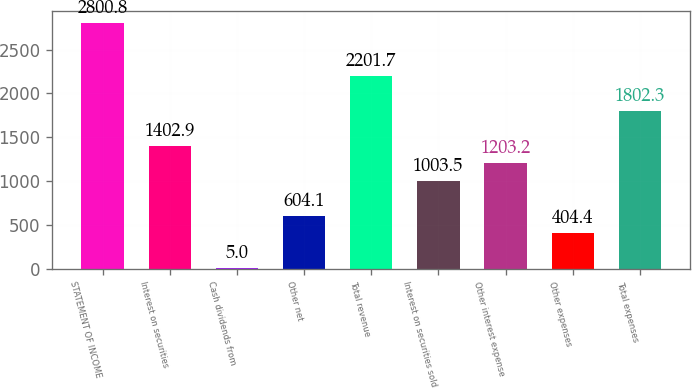Convert chart to OTSL. <chart><loc_0><loc_0><loc_500><loc_500><bar_chart><fcel>STATEMENT OF INCOME<fcel>Interest on securities<fcel>Cash dividends from<fcel>Other net<fcel>Total revenue<fcel>Interest on securities sold<fcel>Other interest expense<fcel>Other expenses<fcel>Total expenses<nl><fcel>2800.8<fcel>1402.9<fcel>5<fcel>604.1<fcel>2201.7<fcel>1003.5<fcel>1203.2<fcel>404.4<fcel>1802.3<nl></chart> 